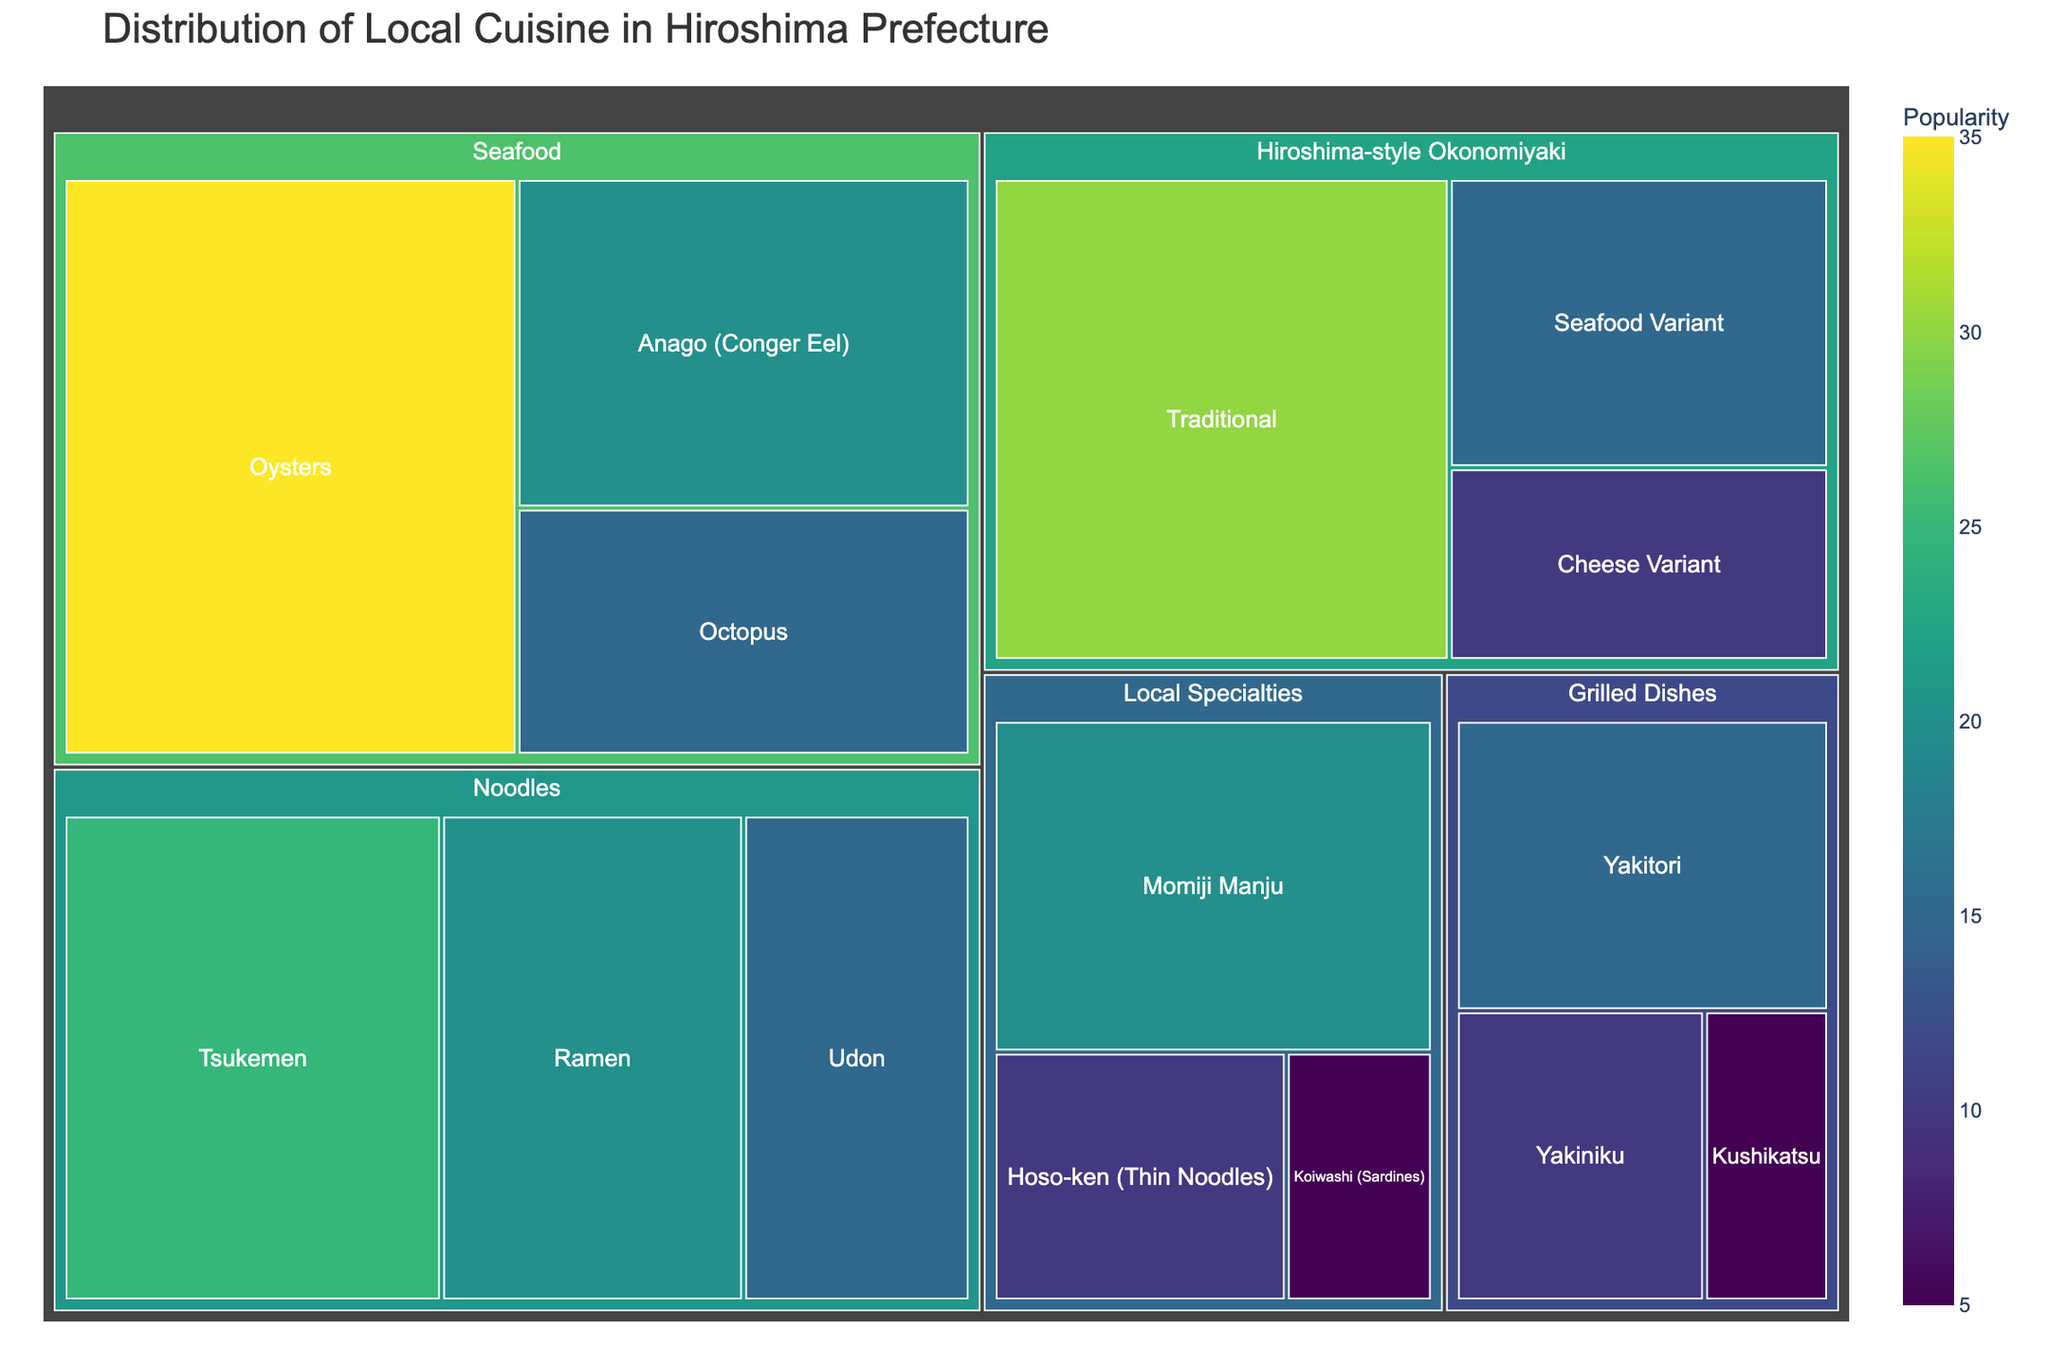What is the title of the figure? The title of the figure is typically displayed prominently at the top. In this case, the title "Distribution of Local Cuisine in Hiroshima Prefecture" can be found there.
Answer: Distribution of Local Cuisine in Hiroshima Prefecture Which local cuisine type has the most popular dish? To determine which local cuisine has the most popular dish, look for the largest single block in the treemap. The largest block represents "Oysters" under the "Seafood" category with a value of 35.
Answer: Seafood What is the combined popularity value of all Hiroshima-style Okonomiyaki variants? Summing the values of "Traditional" (30), "Cheese Variant" (10), and "Seafood Variant" (15) gives 30 + 10 + 15 = 55.
Answer: 55 Which is more popular: Tsukemen or Momiji Manju? Compare the sizes of the blocks representing "Tsukemen" and "Momiji Manju". Tsukemen has a value of 25, while Momiji Manju has a value of 20.
Answer: Tsukemen What is the least popular local specialty dish? From the "Local Specialties" category, "Koiwashi (Sardines)" has the smallest block with a value of 5.
Answer: Koiwashi (Sardines) What is the total popularity value of all Grilled Dishes? Adding the values of "Yakitori" (15), "Yakiniku" (10), and "Kushikatsu" (5) gives 15 + 10 + 5 = 30.
Answer: 30 Which has a higher combined popularity: Noodles or Local Specialties? Summing values for Noodles: Tsukemen (25) + Ramen (20) + Udon (15) = 60. Summing values for Local Specialties: Momiji Manju (20) + Hoso-ken (10) + Koiwashi (5) = 35. Since 60 > 35, Noodles is higher.
Answer: Noodles How many categories have a dish with a value of at least 20? Check each category for dishes with values ≥ 20. Seafood has 2 dishes (Oysters and Anago), Hiroshima-style Okonomiyaki has 1 (Traditional), Noodles have 2 (Tsukemen and Ramen), and Local Specialties has 1 (Momiji Manju). Thus, 4 categories meet this criterion.
Answer: 4 Which cuisine category has the smallest total popularity value? Sum the values for each cuisine category:
- Seafood: 35 + 20 + 15 = 70
- Hiroshima-style Okonomiyaki: 30 + 10 + 15 = 55
- Noodles: 25 + 20 + 15 = 60
- Local Specialties: 20 + 10 + 5 = 35
- Grilled Dishes: 15 + 10 + 5 = 30
Grilled Dishes has the smallest total value of 30.
Answer: Grilled Dishes What is the difference in popularity between the most popular and least popular dishes? The most popular dish is "Oysters" with a value of 35, and the least popular is "Koiwashi (Sardines)" with a value of 5. Therefore, the difference is 35 - 5 = 30.
Answer: 30 